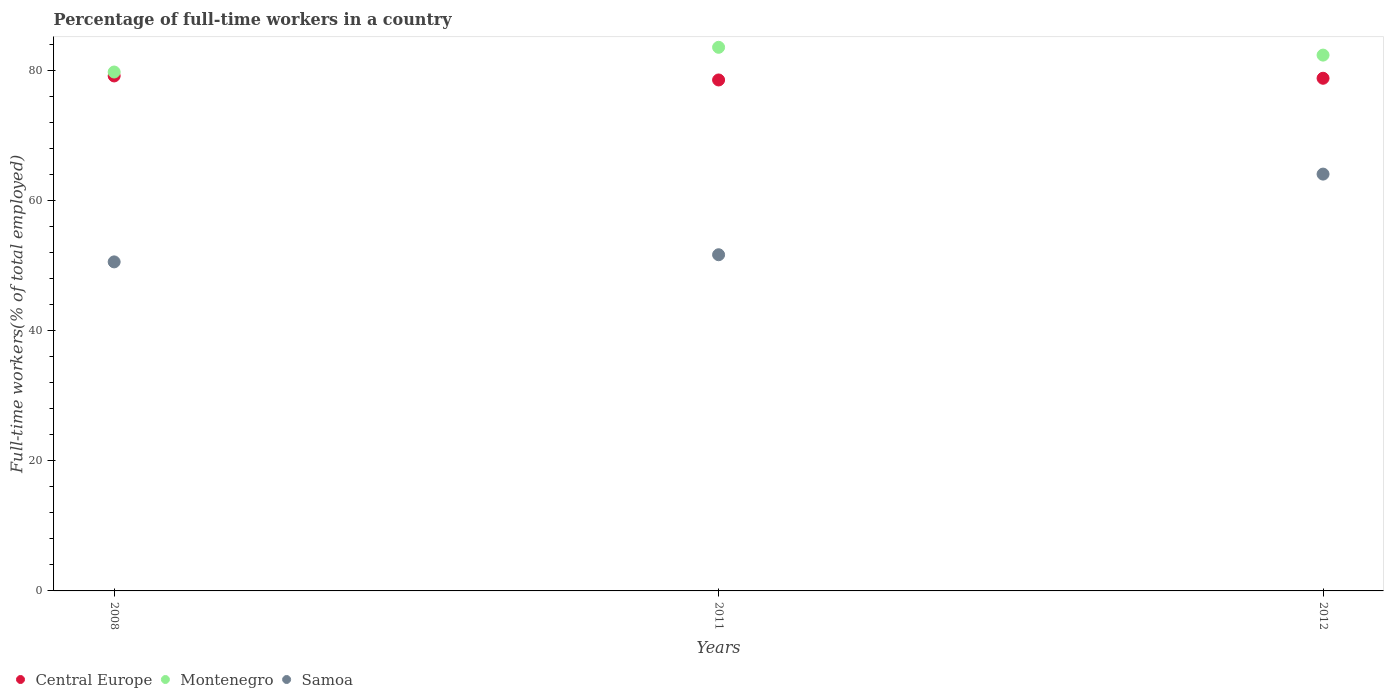How many different coloured dotlines are there?
Keep it short and to the point. 3. What is the percentage of full-time workers in Samoa in 2011?
Offer a very short reply. 51.7. Across all years, what is the maximum percentage of full-time workers in Montenegro?
Your answer should be very brief. 83.6. Across all years, what is the minimum percentage of full-time workers in Central Europe?
Ensure brevity in your answer.  78.58. What is the total percentage of full-time workers in Montenegro in the graph?
Ensure brevity in your answer.  245.8. What is the difference between the percentage of full-time workers in Samoa in 2008 and that in 2011?
Provide a short and direct response. -1.1. What is the difference between the percentage of full-time workers in Montenegro in 2008 and the percentage of full-time workers in Central Europe in 2012?
Give a very brief answer. 0.96. What is the average percentage of full-time workers in Montenegro per year?
Provide a succinct answer. 81.93. In the year 2011, what is the difference between the percentage of full-time workers in Montenegro and percentage of full-time workers in Samoa?
Offer a very short reply. 31.9. What is the ratio of the percentage of full-time workers in Montenegro in 2008 to that in 2012?
Offer a terse response. 0.97. Is the difference between the percentage of full-time workers in Montenegro in 2011 and 2012 greater than the difference between the percentage of full-time workers in Samoa in 2011 and 2012?
Provide a short and direct response. Yes. What is the difference between the highest and the second highest percentage of full-time workers in Montenegro?
Your answer should be compact. 1.2. What is the difference between the highest and the lowest percentage of full-time workers in Montenegro?
Provide a succinct answer. 3.8. Is the sum of the percentage of full-time workers in Montenegro in 2008 and 2012 greater than the maximum percentage of full-time workers in Central Europe across all years?
Your response must be concise. Yes. Is it the case that in every year, the sum of the percentage of full-time workers in Montenegro and percentage of full-time workers in Central Europe  is greater than the percentage of full-time workers in Samoa?
Your answer should be compact. Yes. Is the percentage of full-time workers in Samoa strictly greater than the percentage of full-time workers in Montenegro over the years?
Give a very brief answer. No. Is the percentage of full-time workers in Montenegro strictly less than the percentage of full-time workers in Central Europe over the years?
Make the answer very short. No. How many years are there in the graph?
Provide a short and direct response. 3. What is the difference between two consecutive major ticks on the Y-axis?
Offer a very short reply. 20. How many legend labels are there?
Make the answer very short. 3. How are the legend labels stacked?
Provide a succinct answer. Horizontal. What is the title of the graph?
Give a very brief answer. Percentage of full-time workers in a country. What is the label or title of the X-axis?
Keep it short and to the point. Years. What is the label or title of the Y-axis?
Provide a short and direct response. Full-time workers(% of total employed). What is the Full-time workers(% of total employed) of Central Europe in 2008?
Provide a short and direct response. 79.2. What is the Full-time workers(% of total employed) in Montenegro in 2008?
Your response must be concise. 79.8. What is the Full-time workers(% of total employed) in Samoa in 2008?
Make the answer very short. 50.6. What is the Full-time workers(% of total employed) of Central Europe in 2011?
Keep it short and to the point. 78.58. What is the Full-time workers(% of total employed) of Montenegro in 2011?
Give a very brief answer. 83.6. What is the Full-time workers(% of total employed) of Samoa in 2011?
Offer a very short reply. 51.7. What is the Full-time workers(% of total employed) of Central Europe in 2012?
Provide a short and direct response. 78.84. What is the Full-time workers(% of total employed) in Montenegro in 2012?
Your answer should be very brief. 82.4. What is the Full-time workers(% of total employed) in Samoa in 2012?
Your answer should be very brief. 64.1. Across all years, what is the maximum Full-time workers(% of total employed) of Central Europe?
Your answer should be compact. 79.2. Across all years, what is the maximum Full-time workers(% of total employed) in Montenegro?
Give a very brief answer. 83.6. Across all years, what is the maximum Full-time workers(% of total employed) in Samoa?
Give a very brief answer. 64.1. Across all years, what is the minimum Full-time workers(% of total employed) in Central Europe?
Your response must be concise. 78.58. Across all years, what is the minimum Full-time workers(% of total employed) of Montenegro?
Ensure brevity in your answer.  79.8. Across all years, what is the minimum Full-time workers(% of total employed) of Samoa?
Offer a very short reply. 50.6. What is the total Full-time workers(% of total employed) of Central Europe in the graph?
Your response must be concise. 236.61. What is the total Full-time workers(% of total employed) of Montenegro in the graph?
Keep it short and to the point. 245.8. What is the total Full-time workers(% of total employed) in Samoa in the graph?
Give a very brief answer. 166.4. What is the difference between the Full-time workers(% of total employed) of Central Europe in 2008 and that in 2011?
Make the answer very short. 0.62. What is the difference between the Full-time workers(% of total employed) of Samoa in 2008 and that in 2011?
Your response must be concise. -1.1. What is the difference between the Full-time workers(% of total employed) of Central Europe in 2008 and that in 2012?
Provide a short and direct response. 0.36. What is the difference between the Full-time workers(% of total employed) in Montenegro in 2008 and that in 2012?
Give a very brief answer. -2.6. What is the difference between the Full-time workers(% of total employed) in Samoa in 2008 and that in 2012?
Your answer should be compact. -13.5. What is the difference between the Full-time workers(% of total employed) in Central Europe in 2011 and that in 2012?
Ensure brevity in your answer.  -0.26. What is the difference between the Full-time workers(% of total employed) of Montenegro in 2011 and that in 2012?
Your response must be concise. 1.2. What is the difference between the Full-time workers(% of total employed) of Samoa in 2011 and that in 2012?
Your response must be concise. -12.4. What is the difference between the Full-time workers(% of total employed) in Central Europe in 2008 and the Full-time workers(% of total employed) in Montenegro in 2011?
Provide a succinct answer. -4.4. What is the difference between the Full-time workers(% of total employed) in Central Europe in 2008 and the Full-time workers(% of total employed) in Samoa in 2011?
Offer a terse response. 27.5. What is the difference between the Full-time workers(% of total employed) in Montenegro in 2008 and the Full-time workers(% of total employed) in Samoa in 2011?
Ensure brevity in your answer.  28.1. What is the difference between the Full-time workers(% of total employed) of Central Europe in 2008 and the Full-time workers(% of total employed) of Montenegro in 2012?
Provide a short and direct response. -3.2. What is the difference between the Full-time workers(% of total employed) in Central Europe in 2008 and the Full-time workers(% of total employed) in Samoa in 2012?
Your response must be concise. 15.1. What is the difference between the Full-time workers(% of total employed) in Montenegro in 2008 and the Full-time workers(% of total employed) in Samoa in 2012?
Your response must be concise. 15.7. What is the difference between the Full-time workers(% of total employed) in Central Europe in 2011 and the Full-time workers(% of total employed) in Montenegro in 2012?
Your answer should be compact. -3.82. What is the difference between the Full-time workers(% of total employed) of Central Europe in 2011 and the Full-time workers(% of total employed) of Samoa in 2012?
Your answer should be compact. 14.48. What is the average Full-time workers(% of total employed) in Central Europe per year?
Ensure brevity in your answer.  78.87. What is the average Full-time workers(% of total employed) of Montenegro per year?
Your answer should be very brief. 81.93. What is the average Full-time workers(% of total employed) in Samoa per year?
Provide a succinct answer. 55.47. In the year 2008, what is the difference between the Full-time workers(% of total employed) in Central Europe and Full-time workers(% of total employed) in Montenegro?
Your answer should be very brief. -0.6. In the year 2008, what is the difference between the Full-time workers(% of total employed) of Central Europe and Full-time workers(% of total employed) of Samoa?
Provide a short and direct response. 28.6. In the year 2008, what is the difference between the Full-time workers(% of total employed) of Montenegro and Full-time workers(% of total employed) of Samoa?
Your answer should be very brief. 29.2. In the year 2011, what is the difference between the Full-time workers(% of total employed) of Central Europe and Full-time workers(% of total employed) of Montenegro?
Ensure brevity in your answer.  -5.02. In the year 2011, what is the difference between the Full-time workers(% of total employed) in Central Europe and Full-time workers(% of total employed) in Samoa?
Provide a succinct answer. 26.88. In the year 2011, what is the difference between the Full-time workers(% of total employed) of Montenegro and Full-time workers(% of total employed) of Samoa?
Offer a very short reply. 31.9. In the year 2012, what is the difference between the Full-time workers(% of total employed) of Central Europe and Full-time workers(% of total employed) of Montenegro?
Make the answer very short. -3.56. In the year 2012, what is the difference between the Full-time workers(% of total employed) of Central Europe and Full-time workers(% of total employed) of Samoa?
Make the answer very short. 14.74. What is the ratio of the Full-time workers(% of total employed) of Central Europe in 2008 to that in 2011?
Your answer should be compact. 1.01. What is the ratio of the Full-time workers(% of total employed) in Montenegro in 2008 to that in 2011?
Offer a very short reply. 0.95. What is the ratio of the Full-time workers(% of total employed) of Samoa in 2008 to that in 2011?
Ensure brevity in your answer.  0.98. What is the ratio of the Full-time workers(% of total employed) in Montenegro in 2008 to that in 2012?
Provide a succinct answer. 0.97. What is the ratio of the Full-time workers(% of total employed) of Samoa in 2008 to that in 2012?
Your answer should be very brief. 0.79. What is the ratio of the Full-time workers(% of total employed) of Central Europe in 2011 to that in 2012?
Ensure brevity in your answer.  1. What is the ratio of the Full-time workers(% of total employed) of Montenegro in 2011 to that in 2012?
Your answer should be compact. 1.01. What is the ratio of the Full-time workers(% of total employed) of Samoa in 2011 to that in 2012?
Offer a very short reply. 0.81. What is the difference between the highest and the second highest Full-time workers(% of total employed) in Central Europe?
Your response must be concise. 0.36. What is the difference between the highest and the second highest Full-time workers(% of total employed) of Montenegro?
Offer a terse response. 1.2. What is the difference between the highest and the second highest Full-time workers(% of total employed) in Samoa?
Your answer should be compact. 12.4. What is the difference between the highest and the lowest Full-time workers(% of total employed) in Central Europe?
Provide a short and direct response. 0.62. What is the difference between the highest and the lowest Full-time workers(% of total employed) in Montenegro?
Your answer should be very brief. 3.8. 